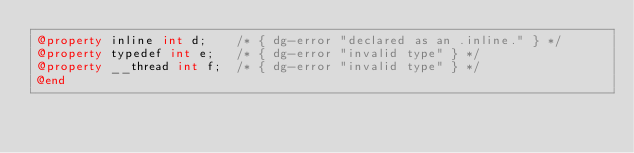Convert code to text. <code><loc_0><loc_0><loc_500><loc_500><_ObjectiveC_>@property inline int d;    /* { dg-error "declared as an .inline." } */
@property typedef int e;   /* { dg-error "invalid type" } */
@property __thread int f;  /* { dg-error "invalid type" } */
@end
</code> 